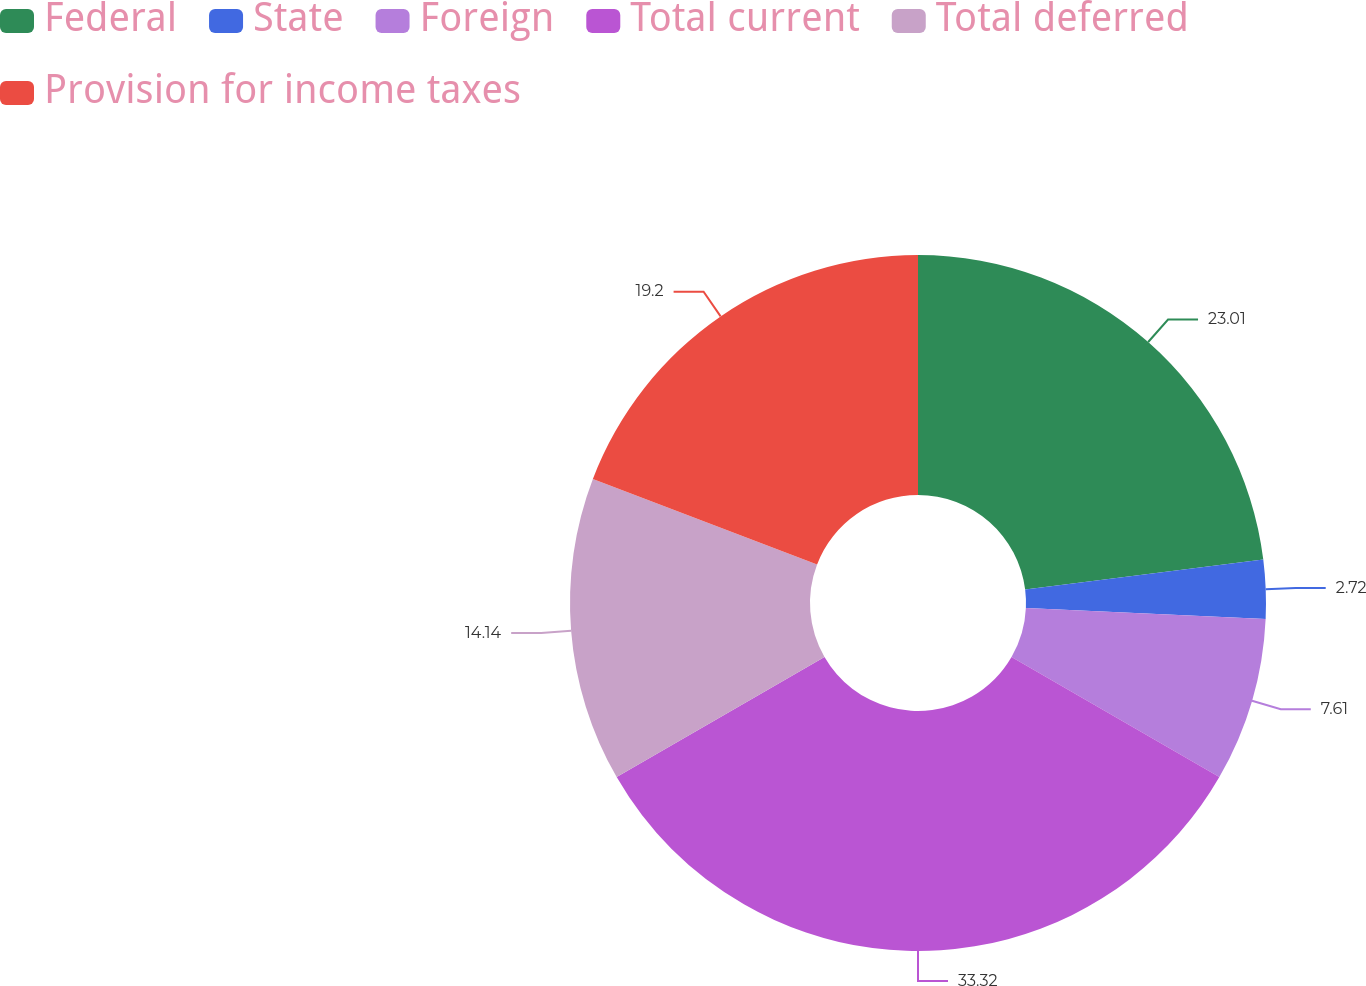<chart> <loc_0><loc_0><loc_500><loc_500><pie_chart><fcel>Federal<fcel>State<fcel>Foreign<fcel>Total current<fcel>Total deferred<fcel>Provision for income taxes<nl><fcel>23.01%<fcel>2.72%<fcel>7.61%<fcel>33.33%<fcel>14.14%<fcel>19.2%<nl></chart> 